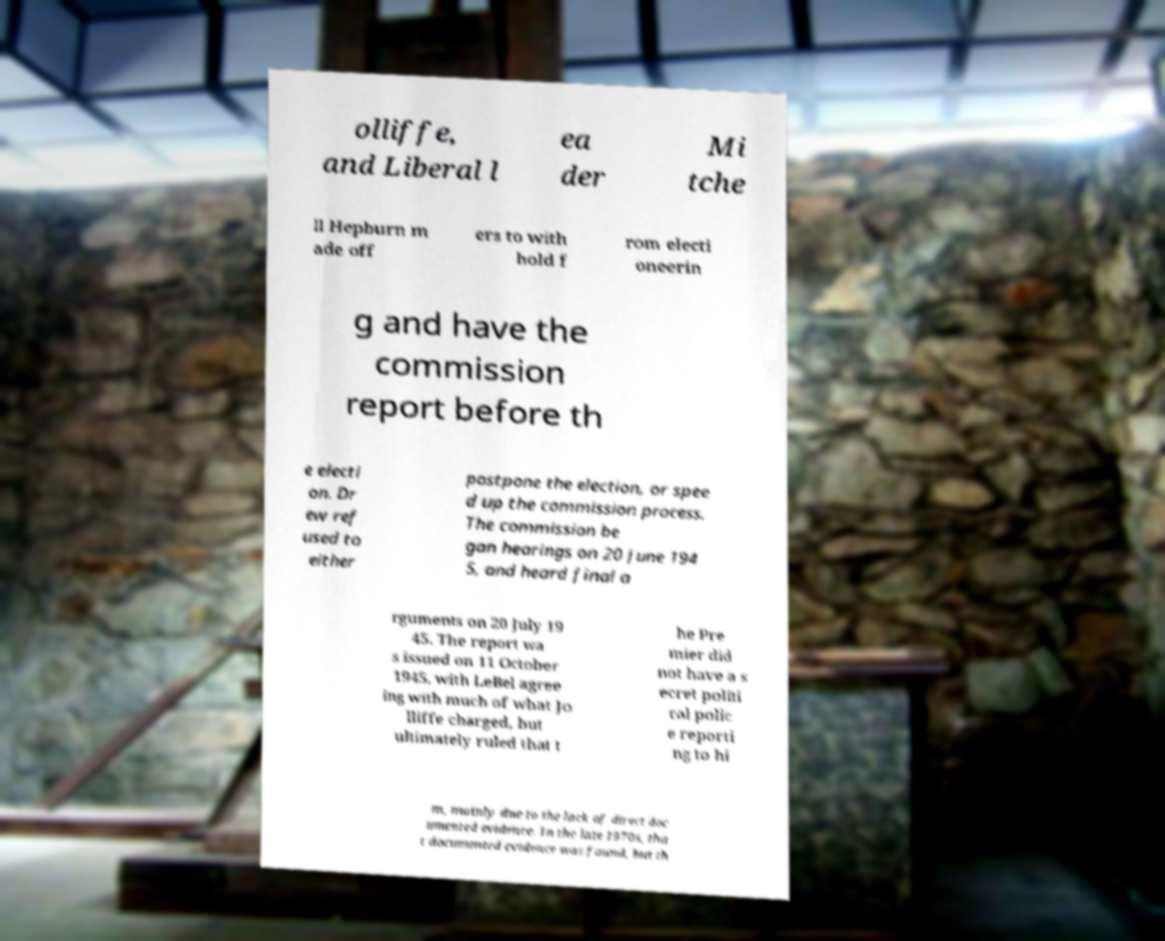I need the written content from this picture converted into text. Can you do that? olliffe, and Liberal l ea der Mi tche ll Hepburn m ade off ers to with hold f rom electi oneerin g and have the commission report before th e electi on. Dr ew ref used to either postpone the election, or spee d up the commission process. The commission be gan hearings on 20 June 194 5, and heard final a rguments on 20 July 19 45. The report wa s issued on 11 October 1945, with LeBel agree ing with much of what Jo lliffe charged, but ultimately ruled that t he Pre mier did not have a s ecret politi cal polic e reporti ng to hi m, mainly due to the lack of direct doc umented evidence. In the late 1970s, tha t documented evidence was found, but th 